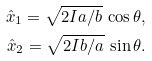Convert formula to latex. <formula><loc_0><loc_0><loc_500><loc_500>\hat { x } _ { 1 } = \sqrt { 2 I a / b } \, \cos \theta , \\ \hat { x } _ { 2 } = \sqrt { 2 I b / a } \, \sin \theta .</formula> 